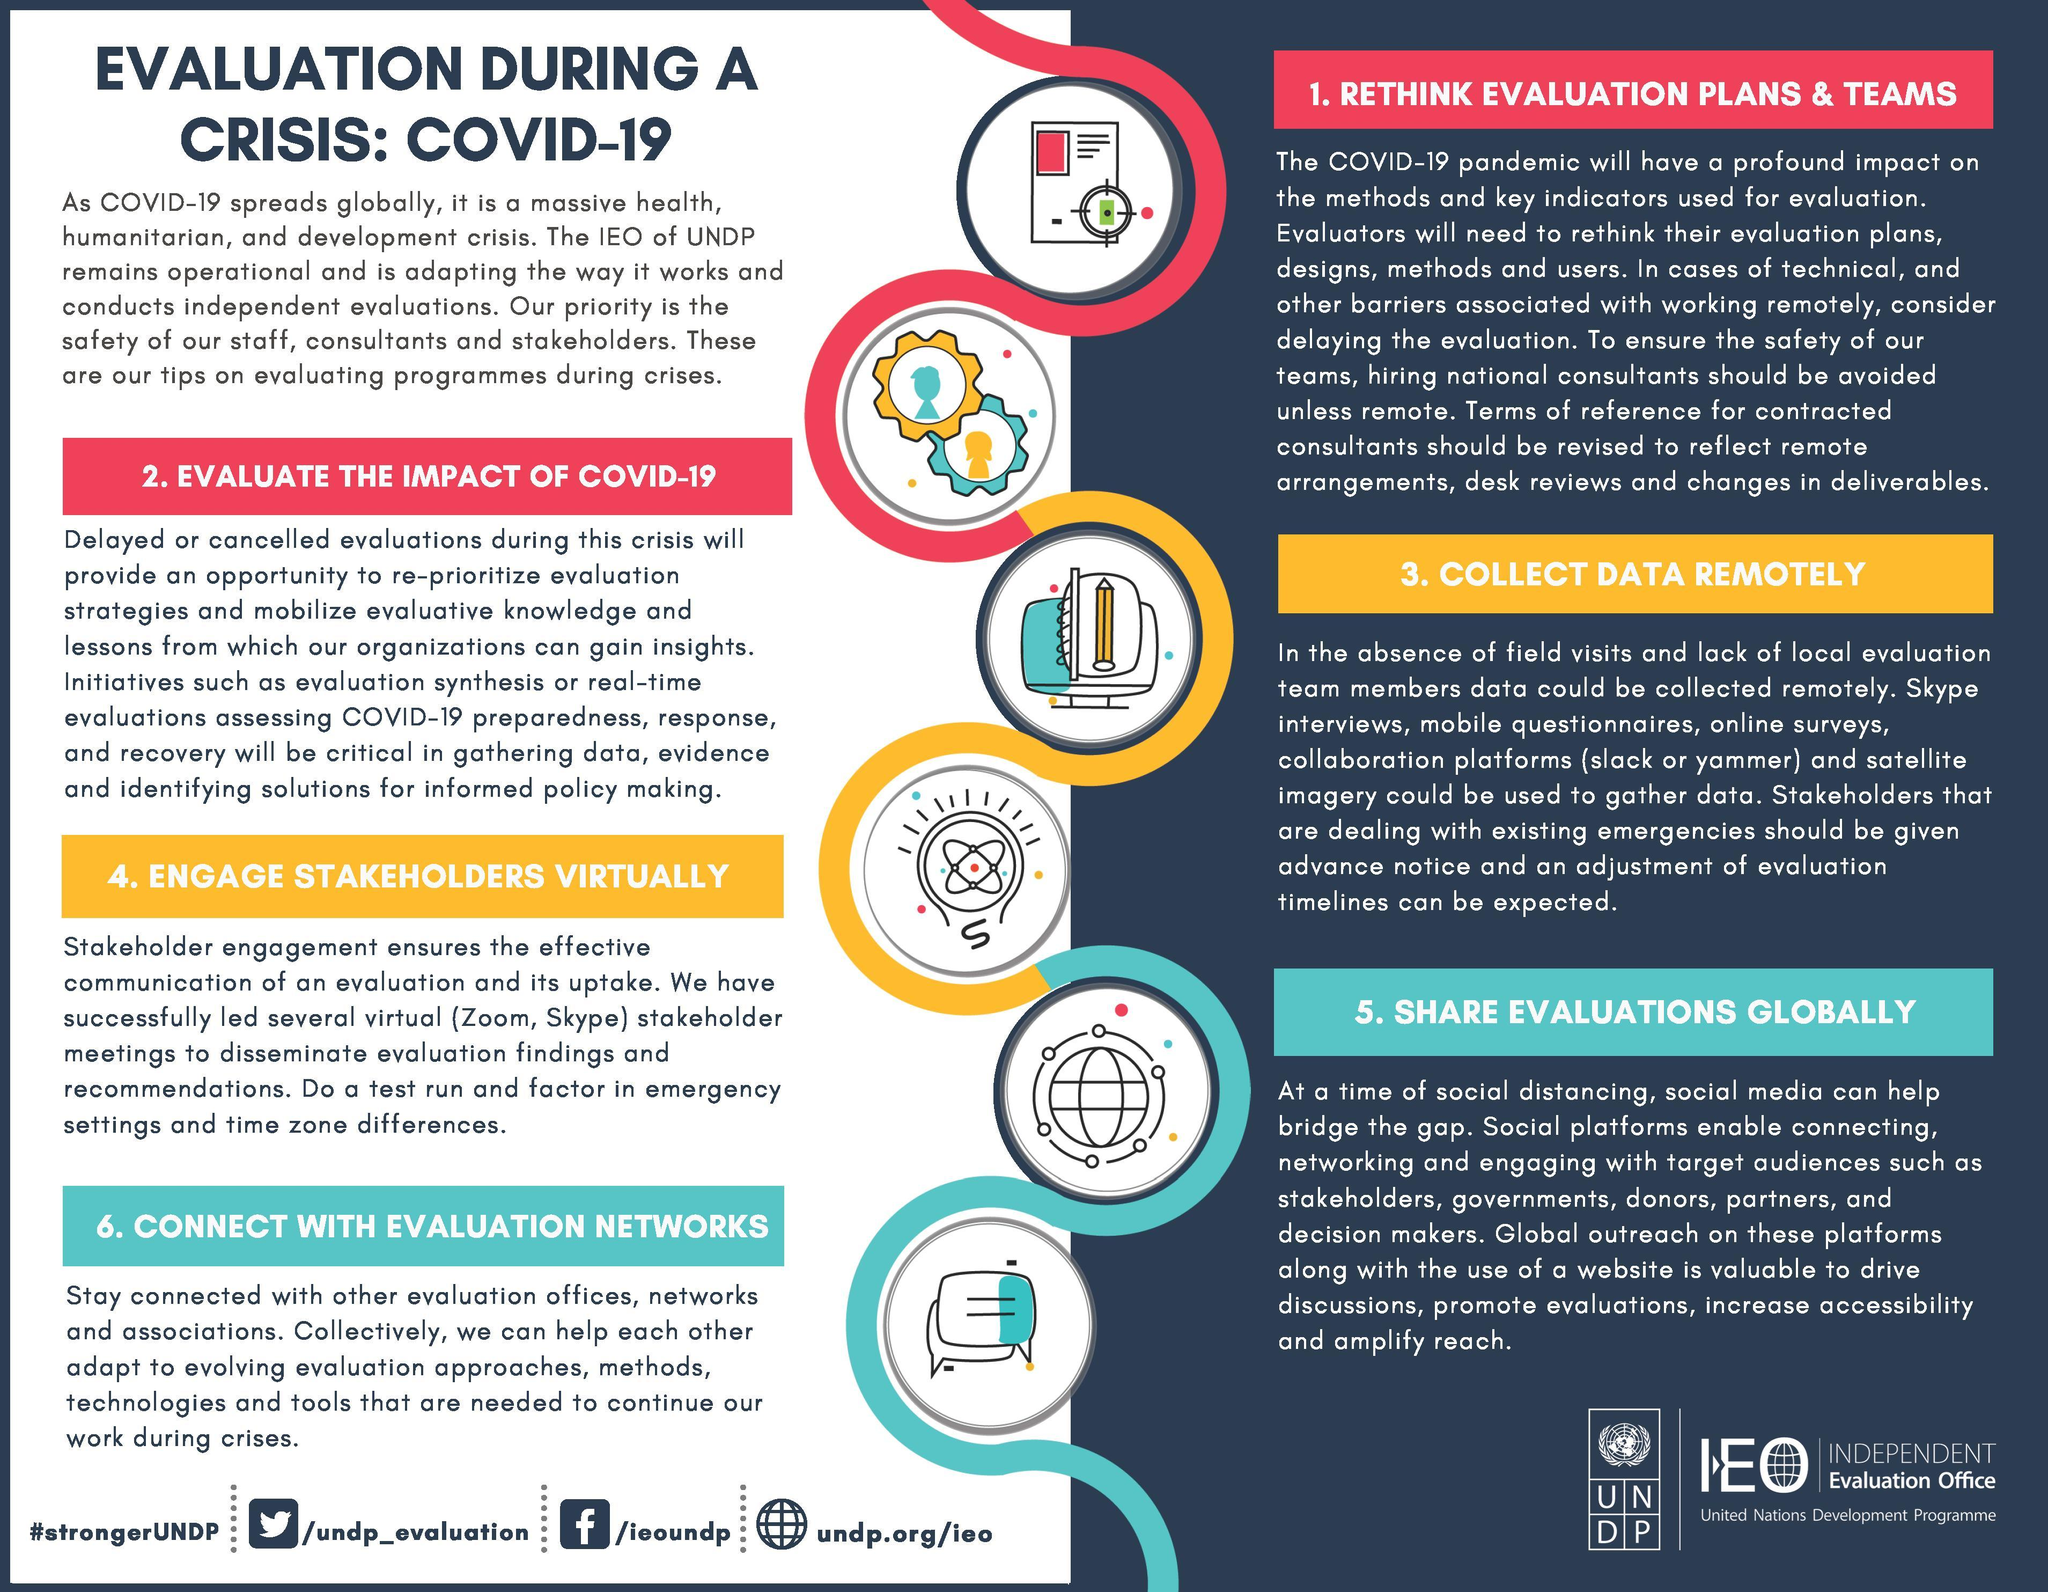What is the third sub topic of this infographic?
Answer the question with a short phrase. 3. collect data remotely What is the second last sub topic of this infographic? share evaluations globally In which color the heading of the third sup topic is highlighted - yellow, red, or green? yellow how many tips are given at the left column of the document? 3 What is the second tip given in this infographic for the evaluation of programs? evaluate the impact of covid-19 In which color the heading of the first sup topic is highlighted - yellow, red, or green? red What is the fourth tip given in this infographic for the evaluation of programs? engage stakeholders virtually How many tips are given in this infographic to help the evaluation process during crisis? 6 which topic is given at the bottom left section? 6. connect with evaluation networks which topic is given at the bottom right section? share evaluations globally 